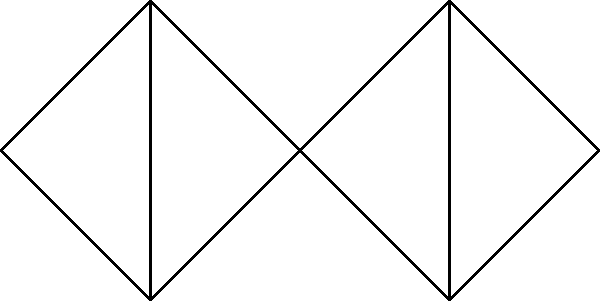In a network representing women's support groups at Point Park University and neighboring institutions, the vertices represent individual groups, and edges represent established collaborations. What is the minimum number of edges that need to be removed to disconnect the graph (i.e., the edge connectivity of the graph)? To find the edge connectivity of this graph, we need to determine the minimum number of edges that, when removed, will disconnect the graph. Let's approach this step-by-step:

1) First, observe that the graph has two main components:
   - Left component: $v_1, v_2, v_3, v_4$
   - Right component: $v_3, v_5, v_6, v_7$

2) These components are connected only through vertex $v_3$.

3) To disconnect the graph, we need to separate these two components. The minimum way to do this is by removing the edges connected to $v_3$ that link it to one of the components.

4) $v_3$ has two edges connecting it to the left component: $v_3-v_2$ and $v_3-v_4$.

5) $v_3$ has two edges connecting it to the right component: $v_3-v_5$ and $v_3-v_7$.

6) We need to remove at least two edges to disconnect $v_3$ from either the left or right component.

7) Removing any two of these edges (one from each component) will disconnect the graph.

Therefore, the edge connectivity of this graph is 2.

This result suggests that the women's support network at Point Park University and neighboring institutions has some vulnerability, as disconnecting just two collaborations could fragment the network. This highlights the importance of fostering multiple strong connections between different groups to enhance the resilience of the support network.
Answer: 2 